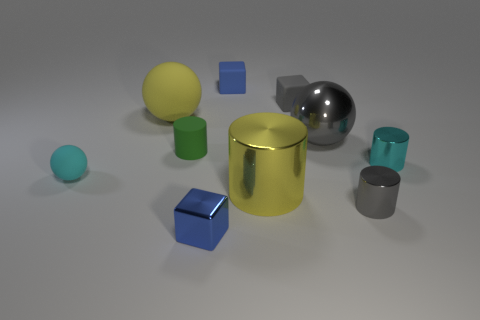Subtract 1 cylinders. How many cylinders are left? 3 Subtract all blue cylinders. Subtract all brown balls. How many cylinders are left? 4 Subtract all cubes. How many objects are left? 7 Add 7 big metal balls. How many big metal balls exist? 8 Subtract 1 green cylinders. How many objects are left? 9 Subtract all small purple blocks. Subtract all spheres. How many objects are left? 7 Add 8 cyan matte objects. How many cyan matte objects are left? 9 